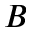Convert formula to latex. <formula><loc_0><loc_0><loc_500><loc_500>B</formula> 